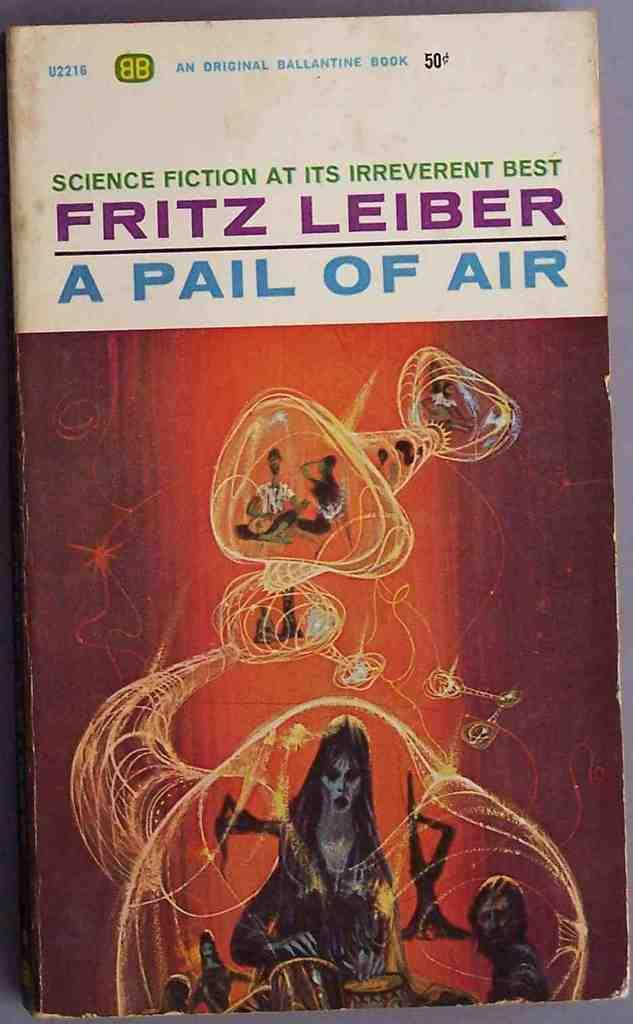<image>
Provide a brief description of the given image. A book titled " Fritz Leiber A Pail of Air" tht is an original ballantine book. 